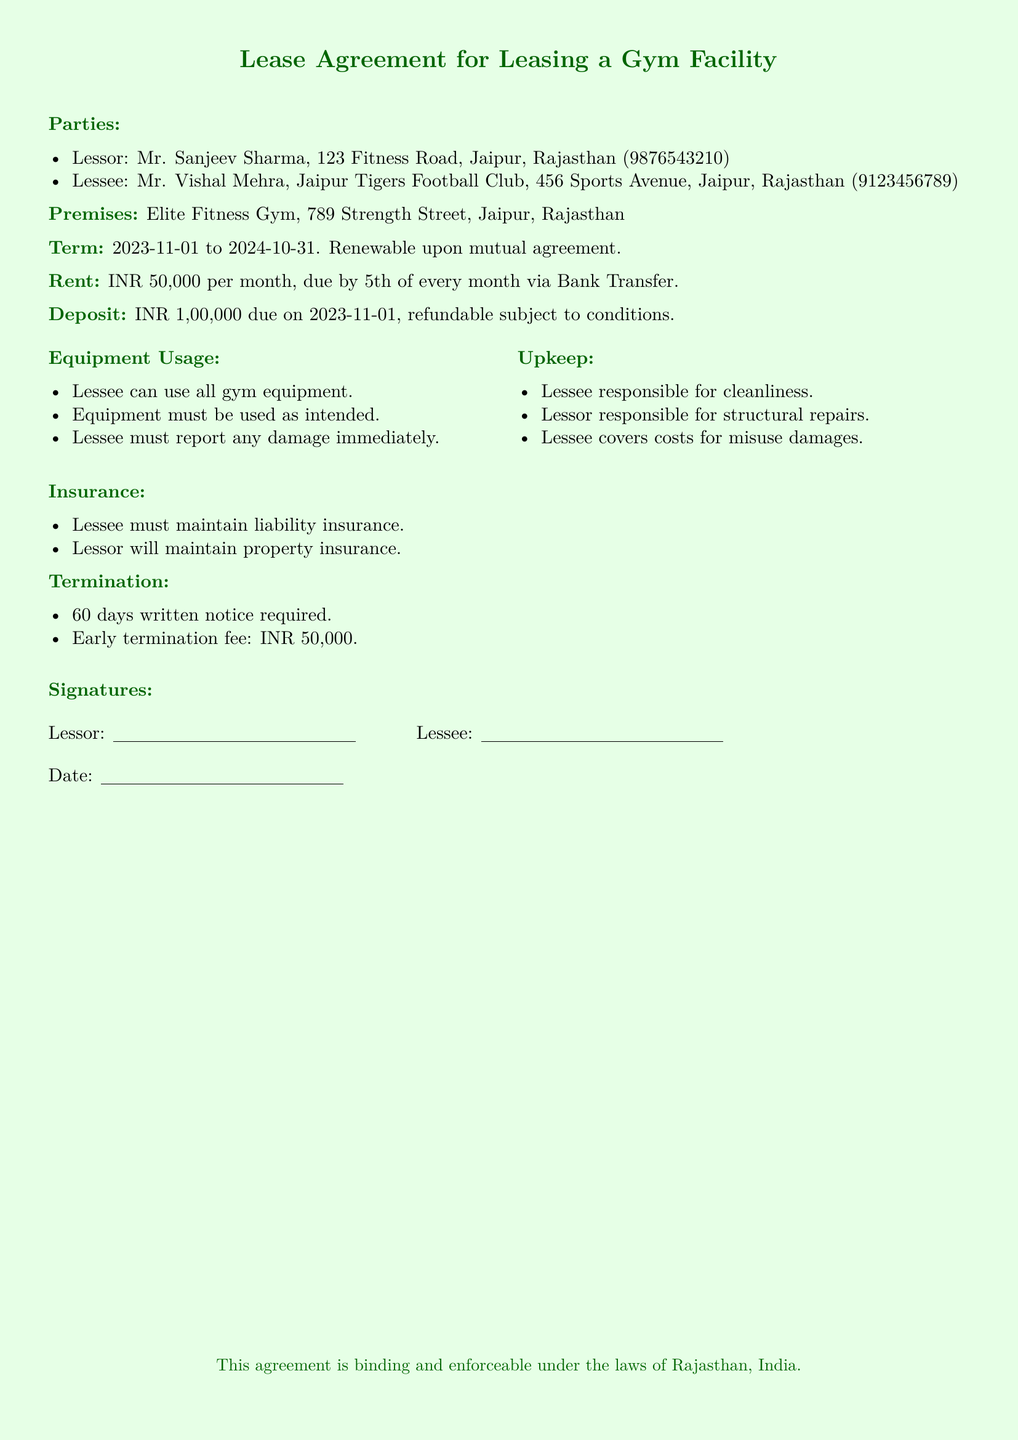What is the name of the lessor? The lessor is identified as Mr. Sanjeev Sharma in the document.
Answer: Mr. Sanjeev Sharma What is the monthly rent amount? The rent specified in the document is INR 50,000 per month.
Answer: INR 50,000 What is the lease term's start date? The lease term starts on November 1, 2023, as stated in the document.
Answer: 2023-11-01 What is the termination notice period? The document states that a 60 days written notice is required for termination.
Answer: 60 days Who is responsible for the upkeep of cleanliness? The lessee is responsible for cleanliness as mentioned in the agreement.
Answer: Lessee What is the early termination fee? The early termination fee is clearly stated as INR 50,000 in the document.
Answer: INR 50,000 What is the name of the gym facility? The name of the gym facility mentioned in the document is Elite Fitness Gym.
Answer: Elite Fitness Gym What insurance must the lessee maintain? The lessee must maintain liability insurance as per the agreement's details.
Answer: Liability insurance 